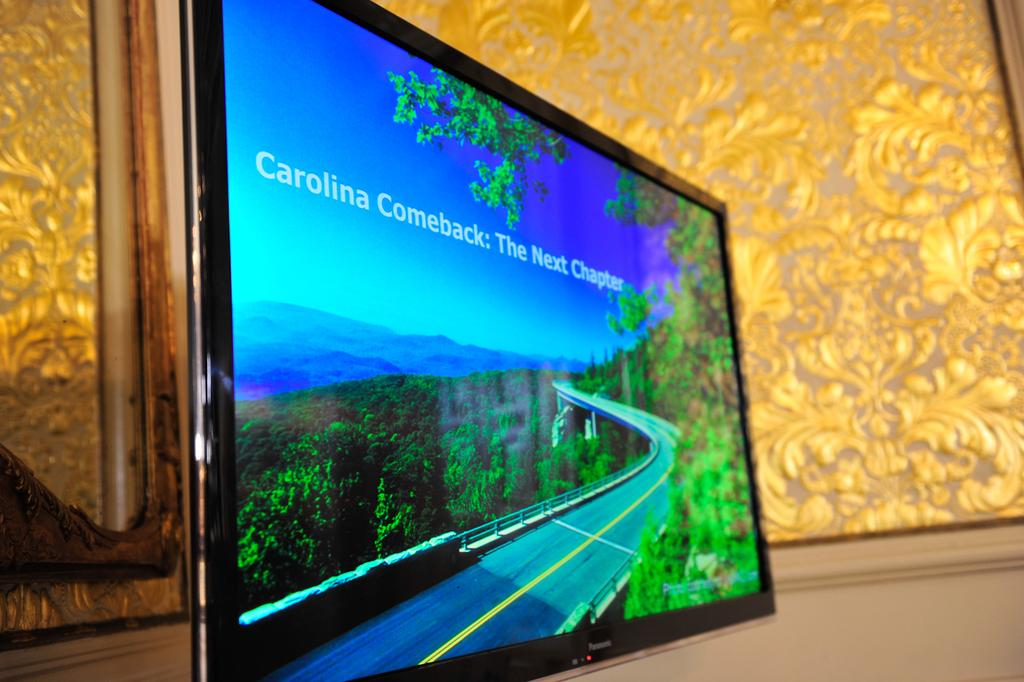<image>
Offer a succinct explanation of the picture presented. a monitor reads Carolina Comeback and is by a gold background 